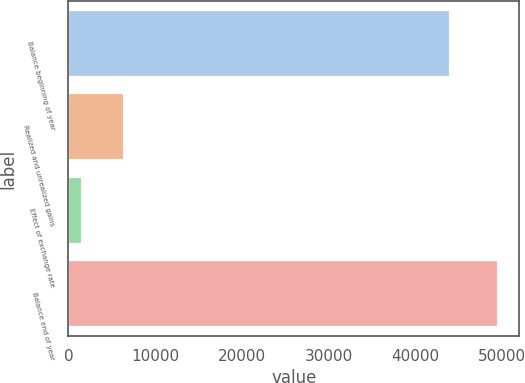Convert chart to OTSL. <chart><loc_0><loc_0><loc_500><loc_500><bar_chart><fcel>Balance beginning of year<fcel>Realized and unrealized gains<fcel>Effect of exchange rate<fcel>Balance end of year<nl><fcel>43997<fcel>6391.9<fcel>1598<fcel>49537<nl></chart> 